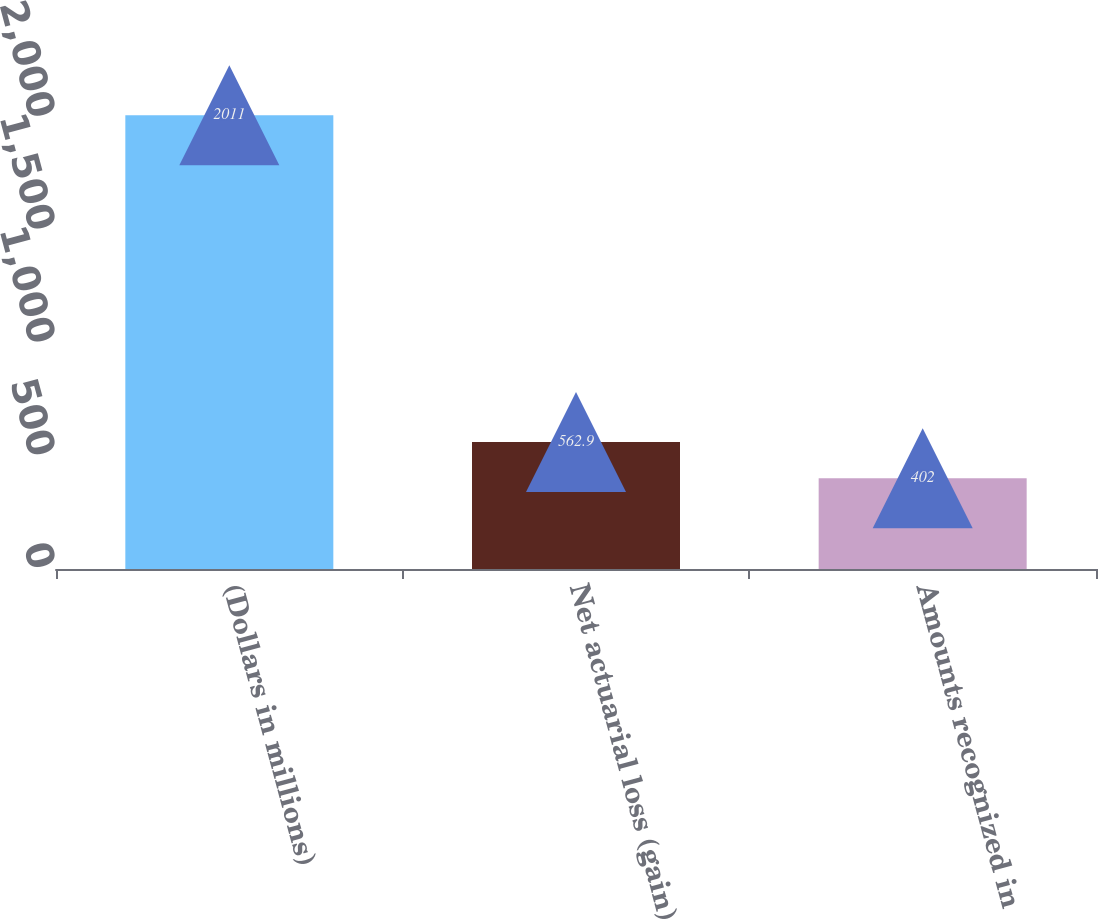Convert chart to OTSL. <chart><loc_0><loc_0><loc_500><loc_500><bar_chart><fcel>(Dollars in millions)<fcel>Net actuarial loss (gain)<fcel>Amounts recognized in<nl><fcel>2011<fcel>562.9<fcel>402<nl></chart> 